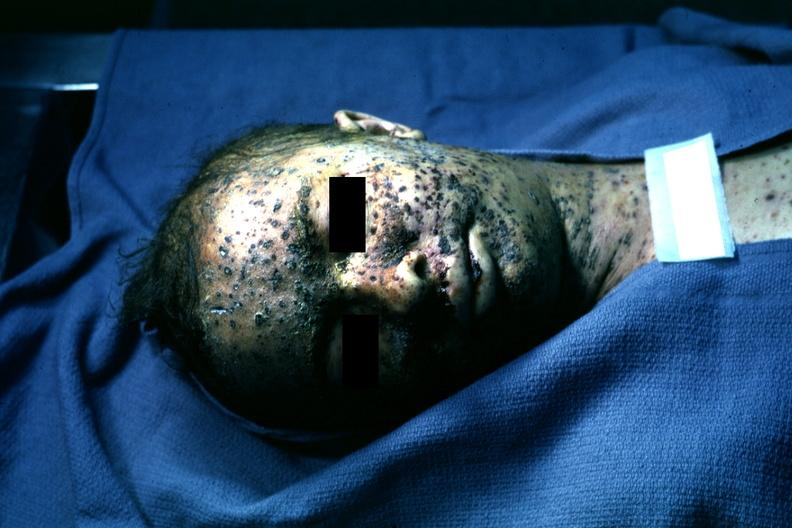s nipples present?
Answer the question using a single word or phrase. No 